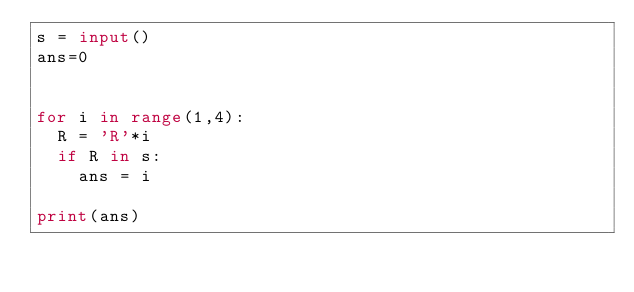<code> <loc_0><loc_0><loc_500><loc_500><_Python_>s = input()
ans=0
 

for i in range(1,4):
  R = 'R'*i
  if R in s:
    ans = i
    
print(ans)</code> 